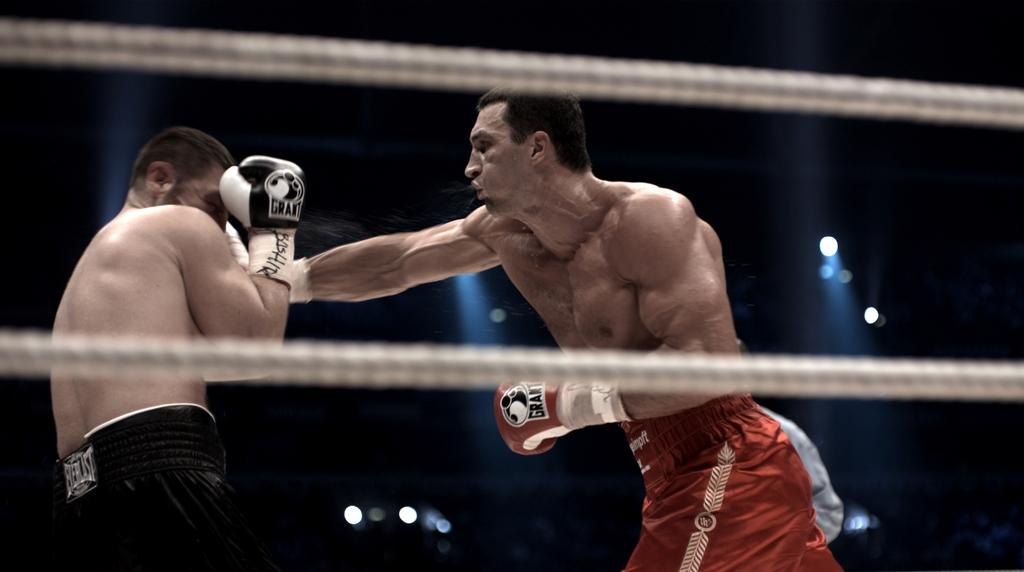What objects can be seen in the image? There are ropes in the image. Are there any people present in the image? Yes, there are people in the image. What are two men wearing in the image? Two men are wearing gloves in the image. What can be seen in the background of the image? There are lights visible in the background of the image. What type of clouds can be seen in the image? There are no clouds present in the image. What nation is represented by the screw in the image? There is no screw present in the image, and therefore no nation can be associated with it. 